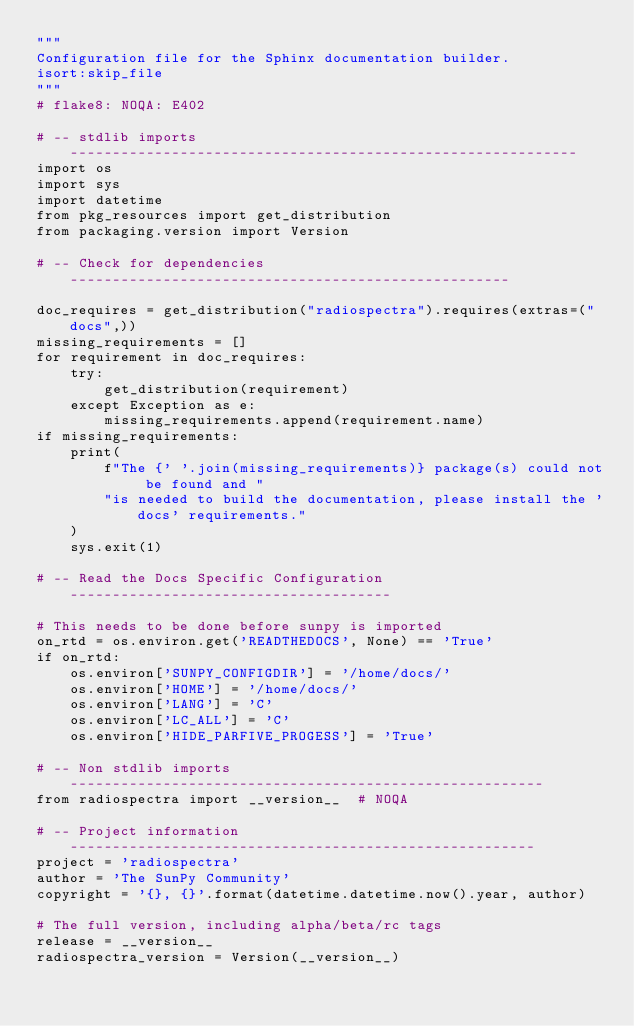<code> <loc_0><loc_0><loc_500><loc_500><_Python_>"""
Configuration file for the Sphinx documentation builder.
isort:skip_file
"""
# flake8: NOQA: E402

# -- stdlib imports ------------------------------------------------------------
import os
import sys
import datetime
from pkg_resources import get_distribution
from packaging.version import Version

# -- Check for dependencies ----------------------------------------------------

doc_requires = get_distribution("radiospectra").requires(extras=("docs",))
missing_requirements = []
for requirement in doc_requires:
    try:
        get_distribution(requirement)
    except Exception as e:
        missing_requirements.append(requirement.name)
if missing_requirements:
    print(
        f"The {' '.join(missing_requirements)} package(s) could not be found and "
        "is needed to build the documentation, please install the 'docs' requirements."
    )
    sys.exit(1)

# -- Read the Docs Specific Configuration --------------------------------------

# This needs to be done before sunpy is imported
on_rtd = os.environ.get('READTHEDOCS', None) == 'True'
if on_rtd:
    os.environ['SUNPY_CONFIGDIR'] = '/home/docs/'
    os.environ['HOME'] = '/home/docs/'
    os.environ['LANG'] = 'C'
    os.environ['LC_ALL'] = 'C'
    os.environ['HIDE_PARFIVE_PROGESS'] = 'True'

# -- Non stdlib imports --------------------------------------------------------
from radiospectra import __version__  # NOQA

# -- Project information -------------------------------------------------------
project = 'radiospectra'
author = 'The SunPy Community'
copyright = '{}, {}'.format(datetime.datetime.now().year, author)

# The full version, including alpha/beta/rc tags
release = __version__
radiospectra_version = Version(__version__)</code> 